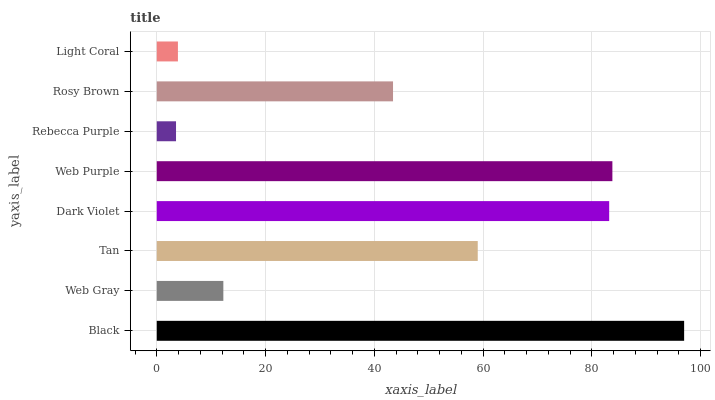Is Rebecca Purple the minimum?
Answer yes or no. Yes. Is Black the maximum?
Answer yes or no. Yes. Is Web Gray the minimum?
Answer yes or no. No. Is Web Gray the maximum?
Answer yes or no. No. Is Black greater than Web Gray?
Answer yes or no. Yes. Is Web Gray less than Black?
Answer yes or no. Yes. Is Web Gray greater than Black?
Answer yes or no. No. Is Black less than Web Gray?
Answer yes or no. No. Is Tan the high median?
Answer yes or no. Yes. Is Rosy Brown the low median?
Answer yes or no. Yes. Is Web Purple the high median?
Answer yes or no. No. Is Light Coral the low median?
Answer yes or no. No. 